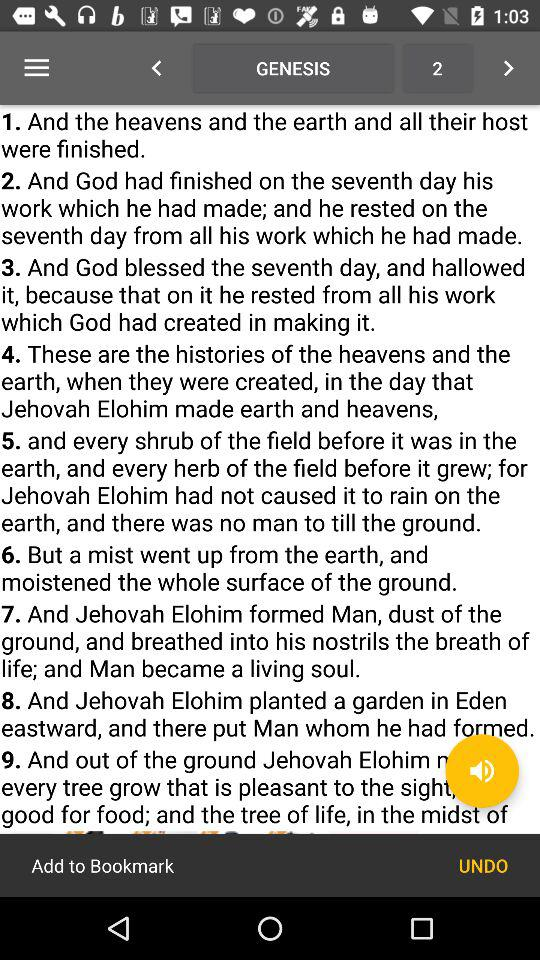Who is a living soul? A living soul is a man. 